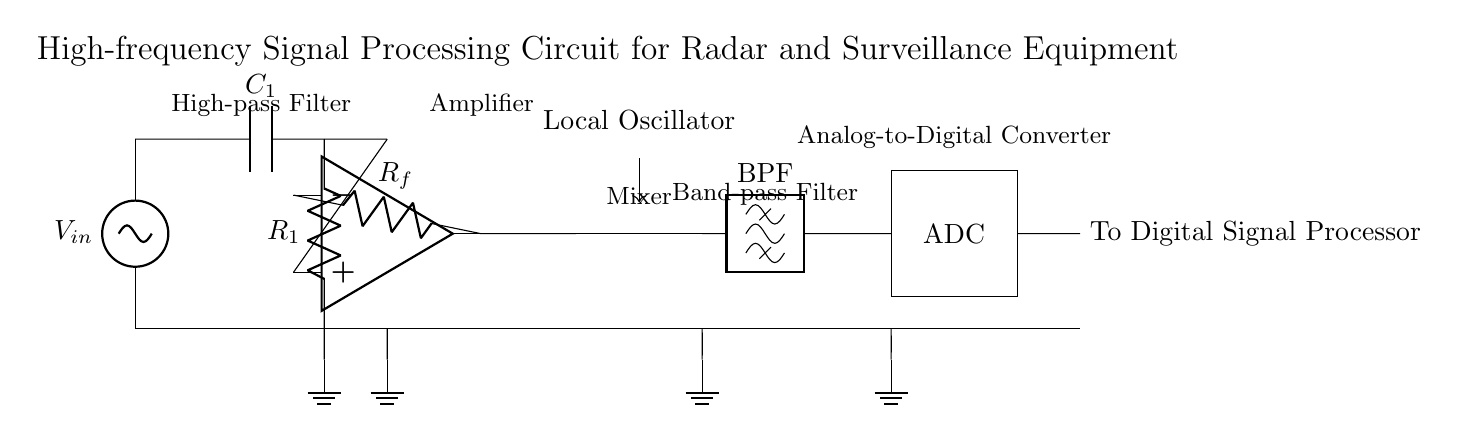What is the first component connected to the input voltage? The circuit shows a capacitor labeled C1 connected right after the input voltage source V_in. This is the first component in the signal path.
Answer: Capacitor C1 What type of filter is used right after the input? A high-pass filter is represented by the capacitor C1 and resistor R1 combination, which allows high-frequency signals to pass while attenuating lower frequencies.
Answer: High-pass filter How is the signal amplified in the circuit? The op-amp, which is positioned in the middle of the circuit, amplifies the signal. The feedback resistor Rf connected from the output back to the inverting pin regulates the gain of the amplifier.
Answer: Op-amp What is the purpose of the mixer in this circuit? The mixer combines the received high-frequency signal with a local oscillator signal to process the radar or surveillance data effectively. This is crucial for signal demodulation.
Answer: Demodulation Which component converts the analog signal to a digital signal? The ADC, indicated by a rectangular box labeled "ADC," is responsible for converting the analog signal processed by previous components into a digital format for further analysis.
Answer: ADC What is the final destination of the processed signal in this circuit? The processed signal outputs to a digital signal processor, indicated by the label "To Digital Signal Processor" at the end of the circuit. This means the adjusted signal will be analyzed further.
Answer: Digital Signal Processor What type of filter is used after the mixer? A band-pass filter is applied after the mixer to isolate desired frequency components while rejecting frequencies outside of a specified range, optimizing the radar signal for processing.
Answer: Band-pass filter 